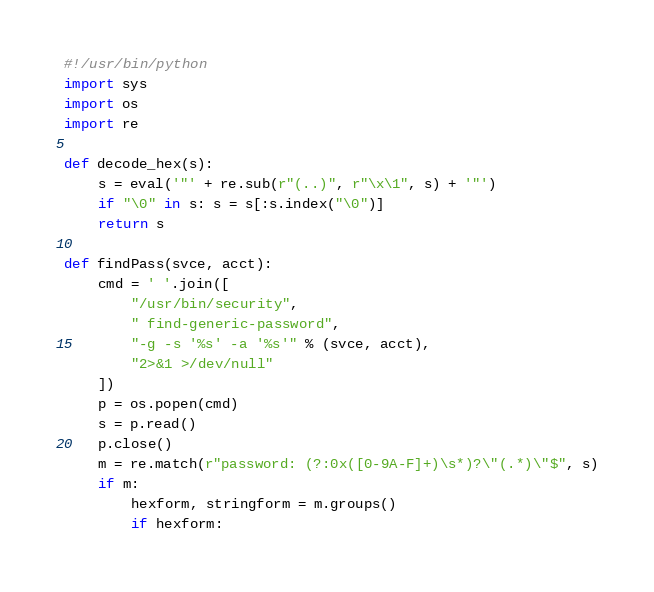<code> <loc_0><loc_0><loc_500><loc_500><_Python_>#!/usr/bin/python
import sys
import os
import re

def decode_hex(s):
    s = eval('"' + re.sub(r"(..)", r"\x\1", s) + '"')
    if "\0" in s: s = s[:s.index("\0")]
    return s

def findPass(svce, acct):
    cmd = ' '.join([
        "/usr/bin/security",
        " find-generic-password",
        "-g -s '%s' -a '%s'" % (svce, acct),
        "2>&1 >/dev/null"
    ])
    p = os.popen(cmd)
    s = p.read()
    p.close()
    m = re.match(r"password: (?:0x([0-9A-F]+)\s*)?\"(.*)\"$", s)
    if m:
        hexform, stringform = m.groups()
        if hexform:</code> 